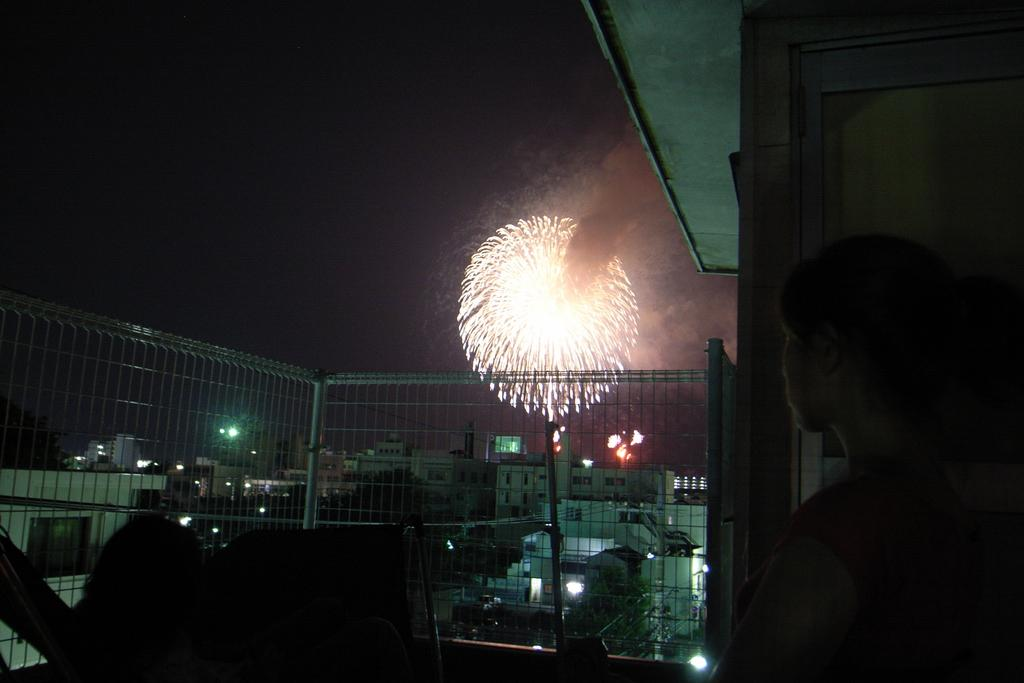What is located in the front of the image? There are persons in the front of the image. What can be seen in the center of the image? There is a fence in the center of the image. What is visible in the background of the image? There are buildings in the background of the image. Can you describe the lights visible in the image? Yes, there are lights visible in the image. What is the unusual object in the air in the image? There is a cracker burning in the air. What type of advertisement can be seen on the carriage in the image? There is no carriage present in the image, and therefore no advertisement can be observed. What happens when the cracker bursts in the image? There is no bursting cracker in the image; it is a cracker burning in the air. 